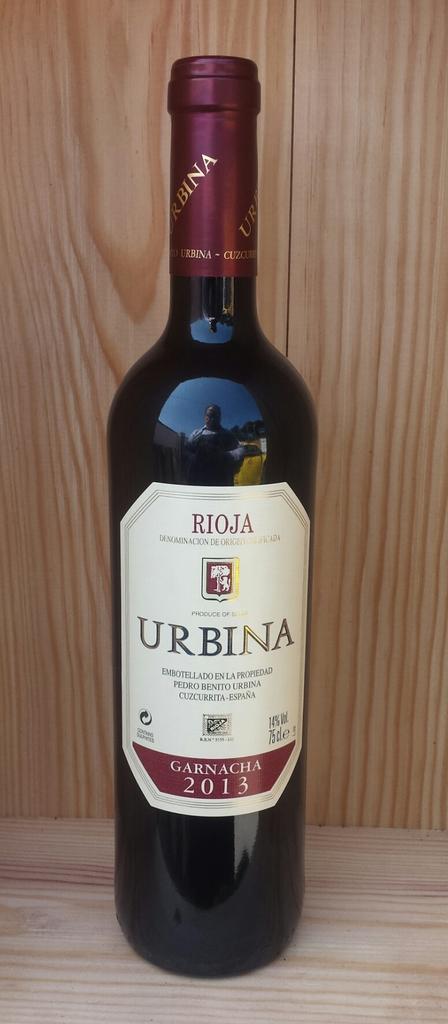What vintage year is the wine?
Your answer should be compact. 2013. What is the name of the wine=?
Offer a very short reply. Urbina. 